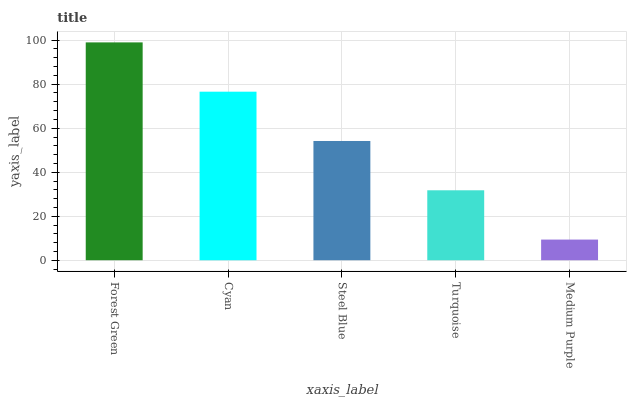Is Medium Purple the minimum?
Answer yes or no. Yes. Is Forest Green the maximum?
Answer yes or no. Yes. Is Cyan the minimum?
Answer yes or no. No. Is Cyan the maximum?
Answer yes or no. No. Is Forest Green greater than Cyan?
Answer yes or no. Yes. Is Cyan less than Forest Green?
Answer yes or no. Yes. Is Cyan greater than Forest Green?
Answer yes or no. No. Is Forest Green less than Cyan?
Answer yes or no. No. Is Steel Blue the high median?
Answer yes or no. Yes. Is Steel Blue the low median?
Answer yes or no. Yes. Is Turquoise the high median?
Answer yes or no. No. Is Medium Purple the low median?
Answer yes or no. No. 